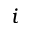<formula> <loc_0><loc_0><loc_500><loc_500>i</formula> 